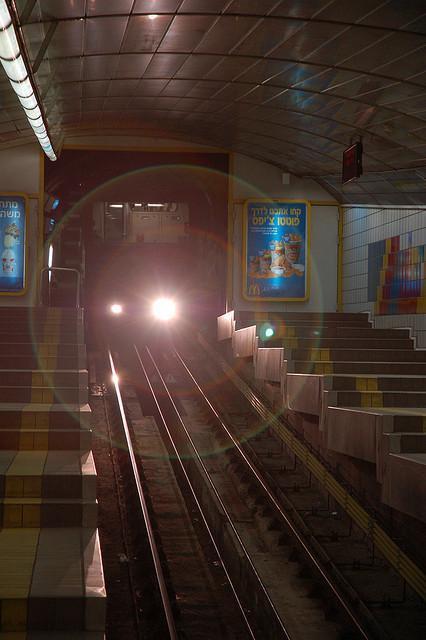How many lights are on?
Give a very brief answer. 2. 